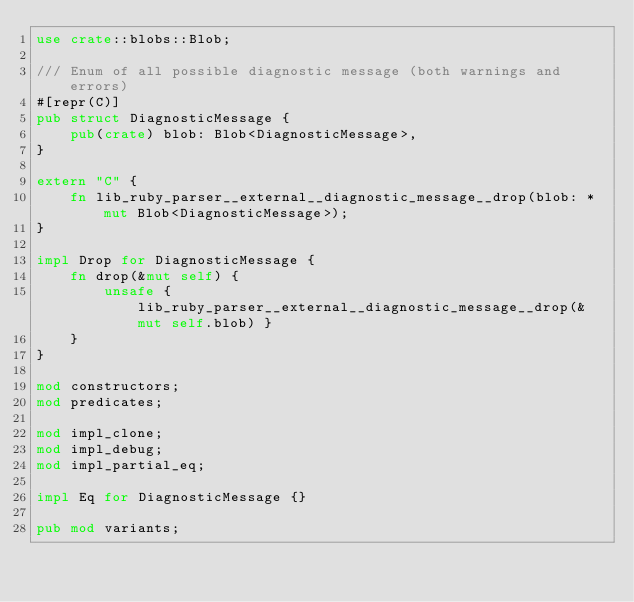Convert code to text. <code><loc_0><loc_0><loc_500><loc_500><_Rust_>use crate::blobs::Blob;

/// Enum of all possible diagnostic message (both warnings and errors)
#[repr(C)]
pub struct DiagnosticMessage {
    pub(crate) blob: Blob<DiagnosticMessage>,
}

extern "C" {
    fn lib_ruby_parser__external__diagnostic_message__drop(blob: *mut Blob<DiagnosticMessage>);
}

impl Drop for DiagnosticMessage {
    fn drop(&mut self) {
        unsafe { lib_ruby_parser__external__diagnostic_message__drop(&mut self.blob) }
    }
}

mod constructors;
mod predicates;

mod impl_clone;
mod impl_debug;
mod impl_partial_eq;

impl Eq for DiagnosticMessage {}

pub mod variants;
</code> 